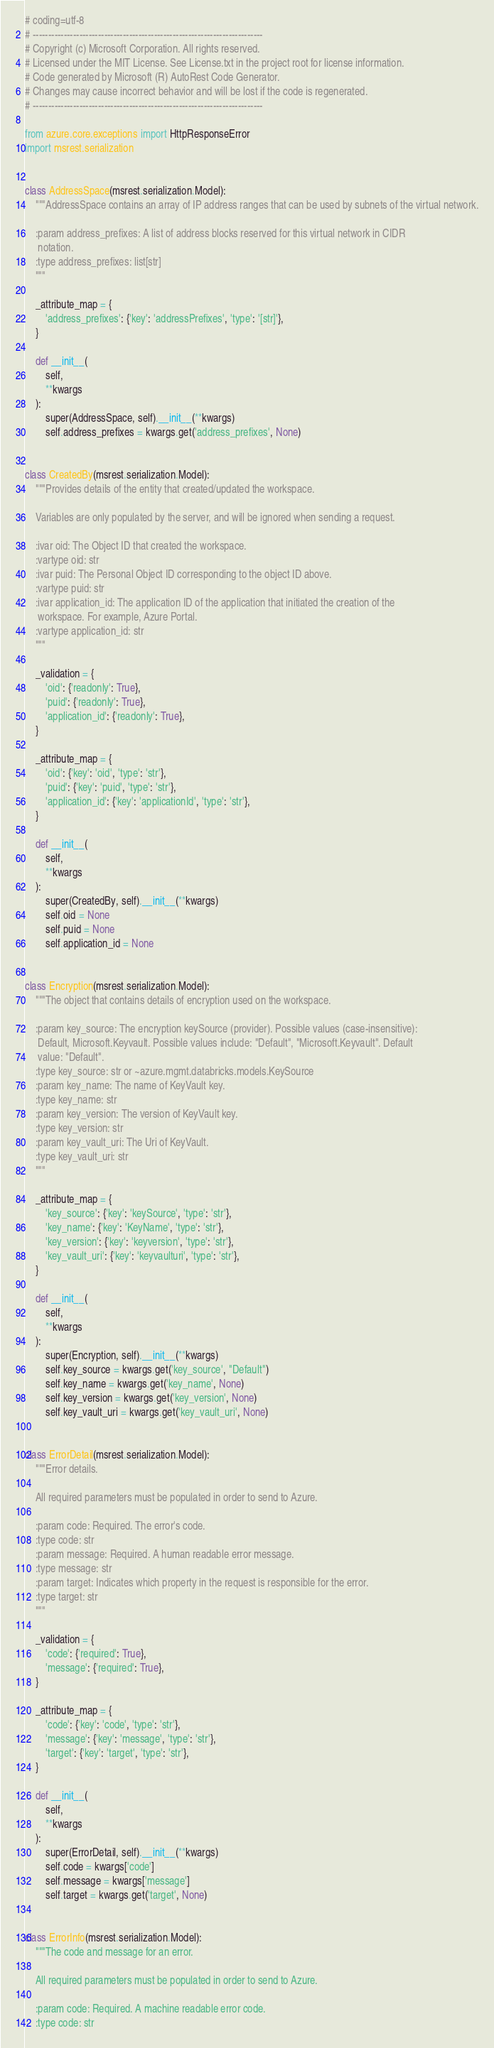Convert code to text. <code><loc_0><loc_0><loc_500><loc_500><_Python_># coding=utf-8
# --------------------------------------------------------------------------
# Copyright (c) Microsoft Corporation. All rights reserved.
# Licensed under the MIT License. See License.txt in the project root for license information.
# Code generated by Microsoft (R) AutoRest Code Generator.
# Changes may cause incorrect behavior and will be lost if the code is regenerated.
# --------------------------------------------------------------------------

from azure.core.exceptions import HttpResponseError
import msrest.serialization


class AddressSpace(msrest.serialization.Model):
    """AddressSpace contains an array of IP address ranges that can be used by subnets of the virtual network.

    :param address_prefixes: A list of address blocks reserved for this virtual network in CIDR
     notation.
    :type address_prefixes: list[str]
    """

    _attribute_map = {
        'address_prefixes': {'key': 'addressPrefixes', 'type': '[str]'},
    }

    def __init__(
        self,
        **kwargs
    ):
        super(AddressSpace, self).__init__(**kwargs)
        self.address_prefixes = kwargs.get('address_prefixes', None)


class CreatedBy(msrest.serialization.Model):
    """Provides details of the entity that created/updated the workspace.

    Variables are only populated by the server, and will be ignored when sending a request.

    :ivar oid: The Object ID that created the workspace.
    :vartype oid: str
    :ivar puid: The Personal Object ID corresponding to the object ID above.
    :vartype puid: str
    :ivar application_id: The application ID of the application that initiated the creation of the
     workspace. For example, Azure Portal.
    :vartype application_id: str
    """

    _validation = {
        'oid': {'readonly': True},
        'puid': {'readonly': True},
        'application_id': {'readonly': True},
    }

    _attribute_map = {
        'oid': {'key': 'oid', 'type': 'str'},
        'puid': {'key': 'puid', 'type': 'str'},
        'application_id': {'key': 'applicationId', 'type': 'str'},
    }

    def __init__(
        self,
        **kwargs
    ):
        super(CreatedBy, self).__init__(**kwargs)
        self.oid = None
        self.puid = None
        self.application_id = None


class Encryption(msrest.serialization.Model):
    """The object that contains details of encryption used on the workspace.

    :param key_source: The encryption keySource (provider). Possible values (case-insensitive):
     Default, Microsoft.Keyvault. Possible values include: "Default", "Microsoft.Keyvault". Default
     value: "Default".
    :type key_source: str or ~azure.mgmt.databricks.models.KeySource
    :param key_name: The name of KeyVault key.
    :type key_name: str
    :param key_version: The version of KeyVault key.
    :type key_version: str
    :param key_vault_uri: The Uri of KeyVault.
    :type key_vault_uri: str
    """

    _attribute_map = {
        'key_source': {'key': 'keySource', 'type': 'str'},
        'key_name': {'key': 'KeyName', 'type': 'str'},
        'key_version': {'key': 'keyversion', 'type': 'str'},
        'key_vault_uri': {'key': 'keyvaulturi', 'type': 'str'},
    }

    def __init__(
        self,
        **kwargs
    ):
        super(Encryption, self).__init__(**kwargs)
        self.key_source = kwargs.get('key_source', "Default")
        self.key_name = kwargs.get('key_name', None)
        self.key_version = kwargs.get('key_version', None)
        self.key_vault_uri = kwargs.get('key_vault_uri', None)


class ErrorDetail(msrest.serialization.Model):
    """Error details.

    All required parameters must be populated in order to send to Azure.

    :param code: Required. The error's code.
    :type code: str
    :param message: Required. A human readable error message.
    :type message: str
    :param target: Indicates which property in the request is responsible for the error.
    :type target: str
    """

    _validation = {
        'code': {'required': True},
        'message': {'required': True},
    }

    _attribute_map = {
        'code': {'key': 'code', 'type': 'str'},
        'message': {'key': 'message', 'type': 'str'},
        'target': {'key': 'target', 'type': 'str'},
    }

    def __init__(
        self,
        **kwargs
    ):
        super(ErrorDetail, self).__init__(**kwargs)
        self.code = kwargs['code']
        self.message = kwargs['message']
        self.target = kwargs.get('target', None)


class ErrorInfo(msrest.serialization.Model):
    """The code and message for an error.

    All required parameters must be populated in order to send to Azure.

    :param code: Required. A machine readable error code.
    :type code: str</code> 